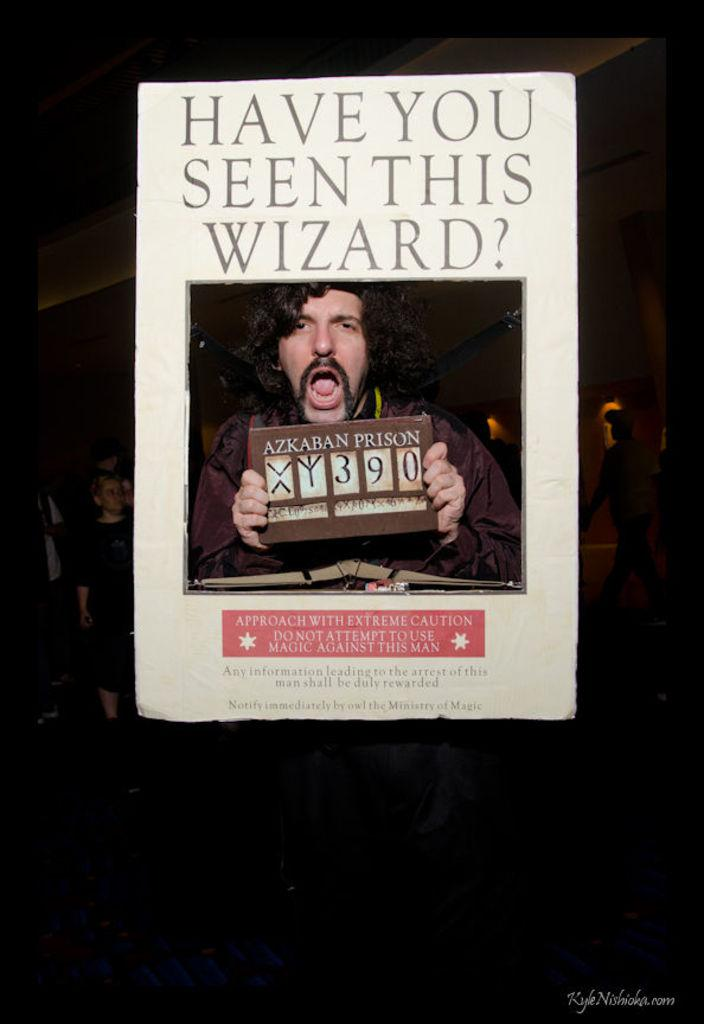What is featured on the poster in the image? There is a poster in the image, and it has the text "Have you seen this wizard?". What can be seen in the photo on the poster? The photo on the poster shows a man holding a board. What is written on the board in the photo? The board has the number 390 written on it. What type of breakfast is the wizard eating in the image? There is no breakfast or wizard eating breakfast present in the image. The poster only has the text "Have you seen this wizard?" and a photo of a man holding a board with the number 390 on it. 